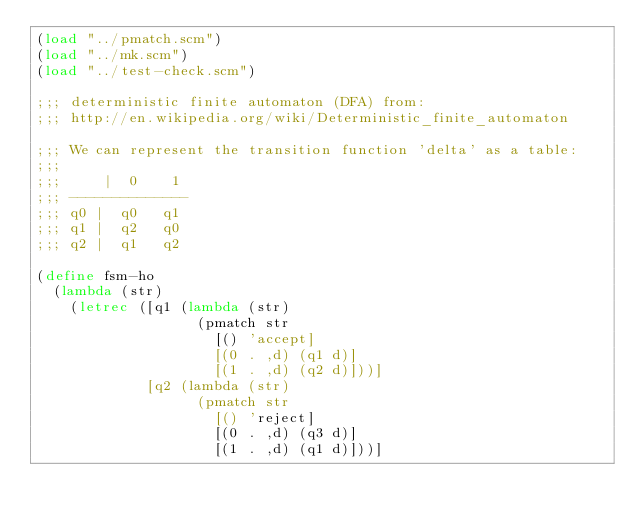Convert code to text. <code><loc_0><loc_0><loc_500><loc_500><_Scheme_>(load "../pmatch.scm")
(load "../mk.scm")
(load "../test-check.scm")

;;; deterministic finite automaton (DFA) from:
;;; http://en.wikipedia.org/wiki/Deterministic_finite_automaton

;;; We can represent the transition function 'delta' as a table:
;;;
;;;     |  0    1
;;; --------------
;;; q0 |  q0   q1
;;; q1 |  q2   q0
;;; q2 |  q1   q2

(define fsm-ho
  (lambda (str)
    (letrec ([q1 (lambda (str)
                   (pmatch str
                     [() 'accept]
                     [(0 . ,d) (q1 d)]
                     [(1 . ,d) (q2 d)]))]
             [q2 (lambda (str)
                   (pmatch str
                     [() 'reject]
                     [(0 . ,d) (q3 d)]
                     [(1 . ,d) (q1 d)]))]</code> 